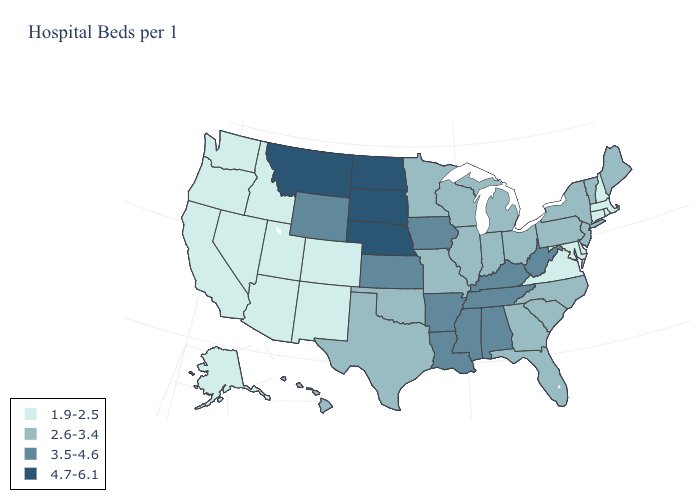Does North Carolina have the same value as Tennessee?
Concise answer only. No. Name the states that have a value in the range 3.5-4.6?
Short answer required. Alabama, Arkansas, Iowa, Kansas, Kentucky, Louisiana, Mississippi, Tennessee, West Virginia, Wyoming. Name the states that have a value in the range 3.5-4.6?
Concise answer only. Alabama, Arkansas, Iowa, Kansas, Kentucky, Louisiana, Mississippi, Tennessee, West Virginia, Wyoming. Does the first symbol in the legend represent the smallest category?
Give a very brief answer. Yes. Among the states that border Utah , does Wyoming have the lowest value?
Short answer required. No. What is the lowest value in states that border Florida?
Short answer required. 2.6-3.4. Among the states that border Minnesota , does South Dakota have the highest value?
Quick response, please. Yes. Name the states that have a value in the range 3.5-4.6?
Quick response, please. Alabama, Arkansas, Iowa, Kansas, Kentucky, Louisiana, Mississippi, Tennessee, West Virginia, Wyoming. Among the states that border Nebraska , which have the lowest value?
Keep it brief. Colorado. What is the value of Arkansas?
Short answer required. 3.5-4.6. Name the states that have a value in the range 2.6-3.4?
Be succinct. Florida, Georgia, Hawaii, Illinois, Indiana, Maine, Michigan, Minnesota, Missouri, New Jersey, New York, North Carolina, Ohio, Oklahoma, Pennsylvania, South Carolina, Texas, Vermont, Wisconsin. Among the states that border Maryland , which have the lowest value?
Concise answer only. Delaware, Virginia. Does South Carolina have the lowest value in the USA?
Answer briefly. No. What is the value of California?
Keep it brief. 1.9-2.5. What is the highest value in the West ?
Keep it brief. 4.7-6.1. 